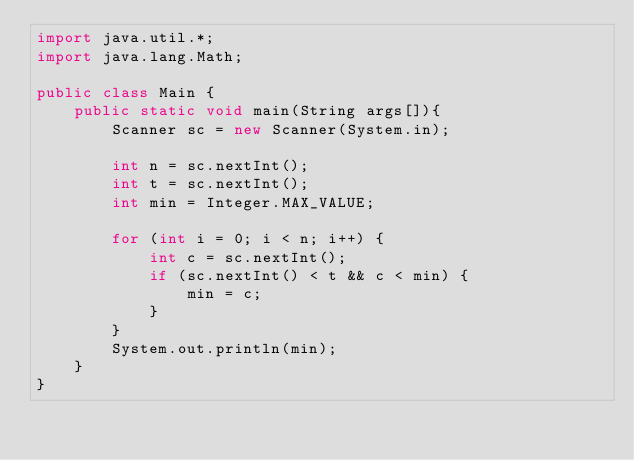<code> <loc_0><loc_0><loc_500><loc_500><_Java_>import java.util.*;
import java.lang.Math;

public class Main {
    public static void main(String args[]){
        Scanner sc = new Scanner(System.in);

        int n = sc.nextInt();
        int t = sc.nextInt();
        int min = Integer.MAX_VALUE;

        for (int i = 0; i < n; i++) {
            int c = sc.nextInt();
            if (sc.nextInt() < t && c < min) {
                min = c;
            }
        }
        System.out.println(min);
    }
}
</code> 